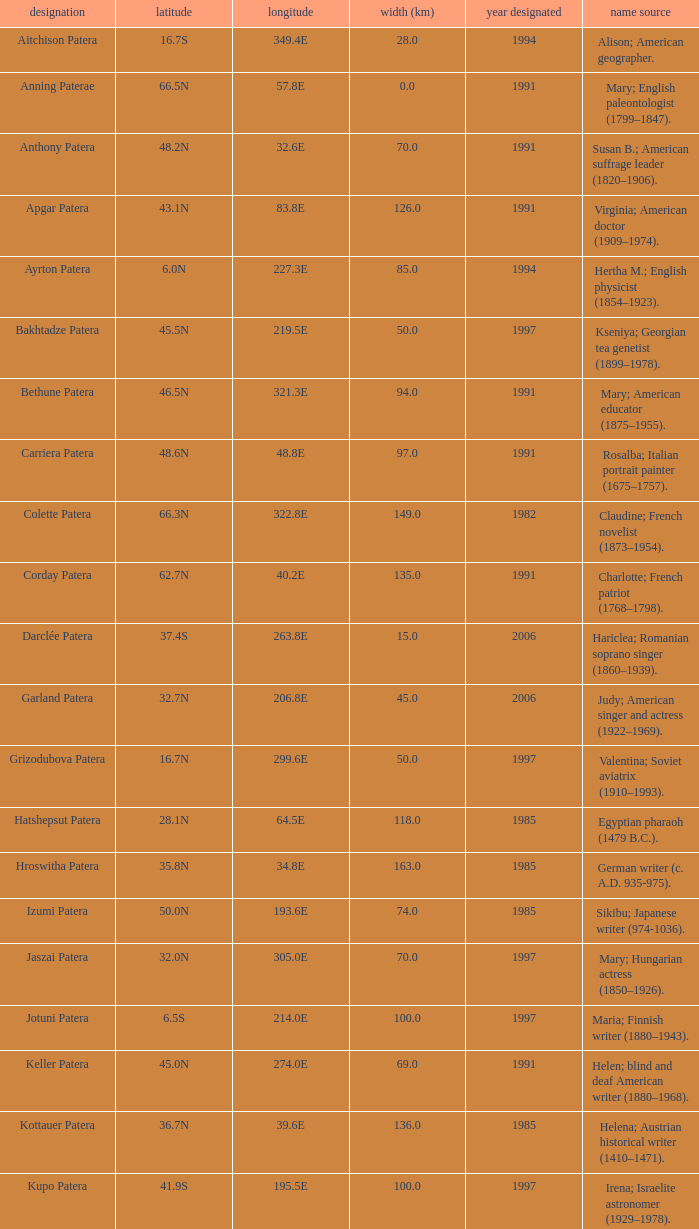Would you mind parsing the complete table? {'header': ['designation', 'latitude', 'longitude', 'width (km)', 'year designated', 'name source'], 'rows': [['Aitchison Patera', '16.7S', '349.4E', '28.0', '1994', 'Alison; American geographer.'], ['Anning Paterae', '66.5N', '57.8E', '0.0', '1991', 'Mary; English paleontologist (1799–1847).'], ['Anthony Patera', '48.2N', '32.6E', '70.0', '1991', 'Susan B.; American suffrage leader (1820–1906).'], ['Apgar Patera', '43.1N', '83.8E', '126.0', '1991', 'Virginia; American doctor (1909–1974).'], ['Ayrton Patera', '6.0N', '227.3E', '85.0', '1994', 'Hertha M.; English physicist (1854–1923).'], ['Bakhtadze Patera', '45.5N', '219.5E', '50.0', '1997', 'Kseniya; Georgian tea genetist (1899–1978).'], ['Bethune Patera', '46.5N', '321.3E', '94.0', '1991', 'Mary; American educator (1875–1955).'], ['Carriera Patera', '48.6N', '48.8E', '97.0', '1991', 'Rosalba; Italian portrait painter (1675–1757).'], ['Colette Patera', '66.3N', '322.8E', '149.0', '1982', 'Claudine; French novelist (1873–1954).'], ['Corday Patera', '62.7N', '40.2E', '135.0', '1991', 'Charlotte; French patriot (1768–1798).'], ['Darclée Patera', '37.4S', '263.8E', '15.0', '2006', 'Hariclea; Romanian soprano singer (1860–1939).'], ['Garland Patera', '32.7N', '206.8E', '45.0', '2006', 'Judy; American singer and actress (1922–1969).'], ['Grizodubova Patera', '16.7N', '299.6E', '50.0', '1997', 'Valentina; Soviet aviatrix (1910–1993).'], ['Hatshepsut Patera', '28.1N', '64.5E', '118.0', '1985', 'Egyptian pharaoh (1479 B.C.).'], ['Hroswitha Patera', '35.8N', '34.8E', '163.0', '1985', 'German writer (c. A.D. 935-975).'], ['Izumi Patera', '50.0N', '193.6E', '74.0', '1985', 'Sikibu; Japanese writer (974-1036).'], ['Jaszai Patera', '32.0N', '305.0E', '70.0', '1997', 'Mary; Hungarian actress (1850–1926).'], ['Jotuni Patera', '6.5S', '214.0E', '100.0', '1997', 'Maria; Finnish writer (1880–1943).'], ['Keller Patera', '45.0N', '274.0E', '69.0', '1991', 'Helen; blind and deaf American writer (1880–1968).'], ['Kottauer Patera', '36.7N', '39.6E', '136.0', '1985', 'Helena; Austrian historical writer (1410–1471).'], ['Kupo Patera', '41.9S', '195.5E', '100.0', '1997', 'Irena; Israelite astronomer (1929–1978).'], ['Ledoux Patera', '9.2S', '224.8E', '75.0', '1994', 'Jeanne; French artist (1767–1840).'], ['Lindgren Patera', '28.1N', '241.4E', '110.0', '2006', 'Astrid; Swedish author (1907–2002).'], ['Mehseti Patera', '16.0N', '311.0E', '60.0', '1997', 'Ganjevi; Azeri/Persian poet (c. 1050-c. 1100).'], ['Mezrina Patera', '33.3S', '68.8E', '60.0', '2000', 'Anna; Russian clay toy sculptor (1853–1938).'], ['Nordenflycht Patera', '35.0S', '266.0E', '140.0', '1997', 'Hedwig; Swedish poet (1718–1763).'], ['Panina Patera', '13.0S', '309.8E', '50.0', '1997', 'Varya; Gypsy/Russian singer (1872–1911).'], ['Payne-Gaposchkin Patera', '25.5S', '196.0E', '100.0', '1997', 'Cecilia Helena; American astronomer (1900–1979).'], ['Pocahontas Patera', '64.9N', '49.4E', '78.0', '1991', 'Powhatan Indian peacemaker (1595–1617).'], ['Raskova Paterae', '51.0S', '222.8E', '80.0', '1994', 'Marina M.; Russian aviator (1912–1943).'], ['Razia Patera', '46.2N', '197.8E', '157.0', '1985', 'Queen of Delhi Sultanate (India) (1236–1240).'], ['Shulzhenko Patera', '6.5N', '264.5E', '60.0', '1997', 'Klavdiya; Soviet singer (1906–1984).'], ['Siddons Patera', '61.6N', '340.6E', '47.0', '1997', 'Sarah; English actress (1755–1831).'], ['Stopes Patera', '42.6N', '46.5E', '169.0', '1991', 'Marie; English paleontologist (1880–1959).'], ['Tarbell Patera', '58.2S', '351.5E', '80.0', '1994', 'Ida; American author, editor (1857–1944).'], ['Teasdale Patera', '67.6S', '189.1E', '75.0', '1994', 'Sara; American poet (1884–1933).'], ['Tey Patera', '17.8S', '349.1E', '20.0', '1994', 'Josephine; Scottish author (1897–1952).'], ['Tipporah Patera', '38.9N', '43.0E', '99.0', '1985', 'Hebrew medical scholar (1500 B.C.).'], ['Vibert-Douglas Patera', '11.6S', '194.3E', '45.0', '2003', 'Allie; Canadian astronomer (1894–1988).'], ['Villepreux-Power Patera', '22.0S', '210.0E', '100.0', '1997', 'Jeannette; French marine biologist (1794–1871).'], ['Wilde Patera', '21.3S', '266.3E', '75.0', '2000', 'Lady Jane Francesca; Irish poet (1821–1891).'], ['Witte Patera', '25.8S', '247.65E', '35.0', '2006', 'Wilhelmine; German astronomer (1777–1854).'], ['Woodhull Patera', '37.4N', '305.4E', '83.0', '1991', 'Victoria; American-English lecturer (1838–1927).']]} What is the diameter in km of the feature named Colette Patera?  149.0. 